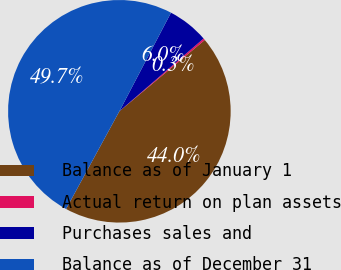Convert chart. <chart><loc_0><loc_0><loc_500><loc_500><pie_chart><fcel>Balance as of January 1<fcel>Actual return on plan assets<fcel>Purchases sales and<fcel>Balance as of December 31<nl><fcel>44.02%<fcel>0.27%<fcel>5.98%<fcel>49.73%<nl></chart> 